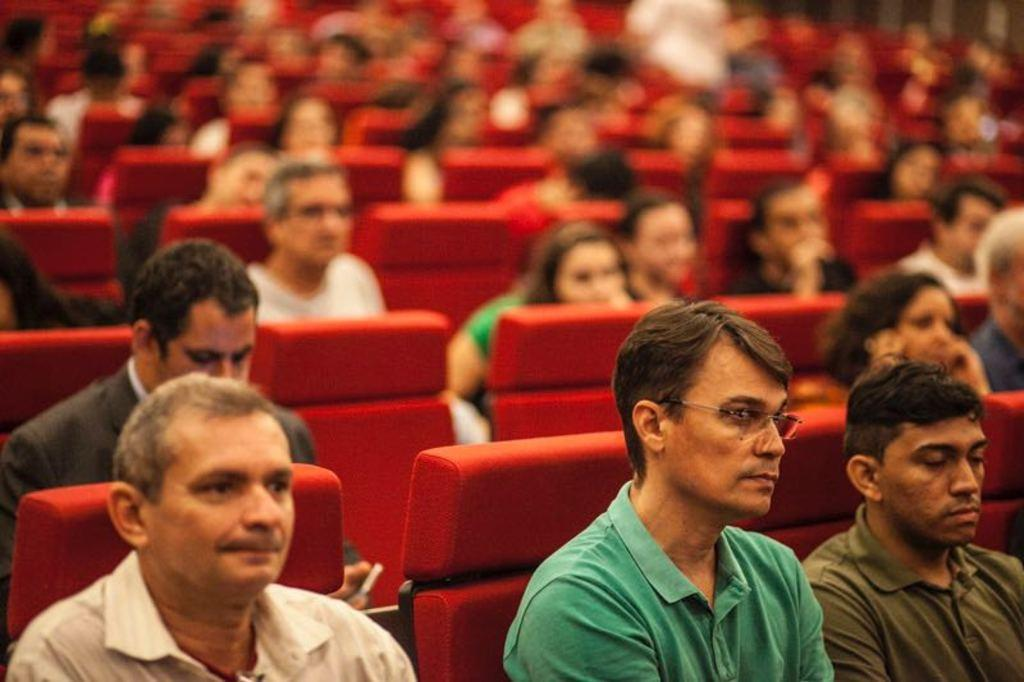Who or what is present in the image? There are people in the image. What are the people doing in the image? The people are sitting on chairs. Can you describe the background of the image? The background of the image is blurry. What type of berry can be seen on the table in the image? There is no berry present in the image; it only features people sitting on chairs with a blurry background. 